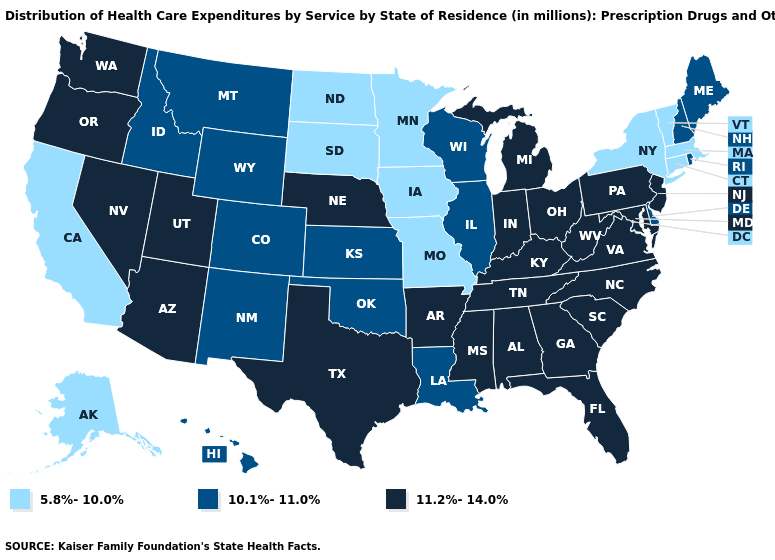Does the first symbol in the legend represent the smallest category?
Keep it brief. Yes. Name the states that have a value in the range 11.2%-14.0%?
Concise answer only. Alabama, Arizona, Arkansas, Florida, Georgia, Indiana, Kentucky, Maryland, Michigan, Mississippi, Nebraska, Nevada, New Jersey, North Carolina, Ohio, Oregon, Pennsylvania, South Carolina, Tennessee, Texas, Utah, Virginia, Washington, West Virginia. Is the legend a continuous bar?
Concise answer only. No. What is the value of Virginia?
Answer briefly. 11.2%-14.0%. Does Oregon have the lowest value in the West?
Concise answer only. No. Does Arizona have a higher value than Georgia?
Concise answer only. No. Name the states that have a value in the range 11.2%-14.0%?
Concise answer only. Alabama, Arizona, Arkansas, Florida, Georgia, Indiana, Kentucky, Maryland, Michigan, Mississippi, Nebraska, Nevada, New Jersey, North Carolina, Ohio, Oregon, Pennsylvania, South Carolina, Tennessee, Texas, Utah, Virginia, Washington, West Virginia. Name the states that have a value in the range 10.1%-11.0%?
Be succinct. Colorado, Delaware, Hawaii, Idaho, Illinois, Kansas, Louisiana, Maine, Montana, New Hampshire, New Mexico, Oklahoma, Rhode Island, Wisconsin, Wyoming. Does the map have missing data?
Answer briefly. No. Does Hawaii have the lowest value in the USA?
Short answer required. No. Name the states that have a value in the range 5.8%-10.0%?
Answer briefly. Alaska, California, Connecticut, Iowa, Massachusetts, Minnesota, Missouri, New York, North Dakota, South Dakota, Vermont. What is the value of Missouri?
Write a very short answer. 5.8%-10.0%. What is the value of Wyoming?
Be succinct. 10.1%-11.0%. Name the states that have a value in the range 5.8%-10.0%?
Write a very short answer. Alaska, California, Connecticut, Iowa, Massachusetts, Minnesota, Missouri, New York, North Dakota, South Dakota, Vermont. Among the states that border Connecticut , which have the lowest value?
Keep it brief. Massachusetts, New York. 